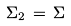Convert formula to latex. <formula><loc_0><loc_0><loc_500><loc_500>\Sigma _ { 2 } \, = \, \Sigma</formula> 